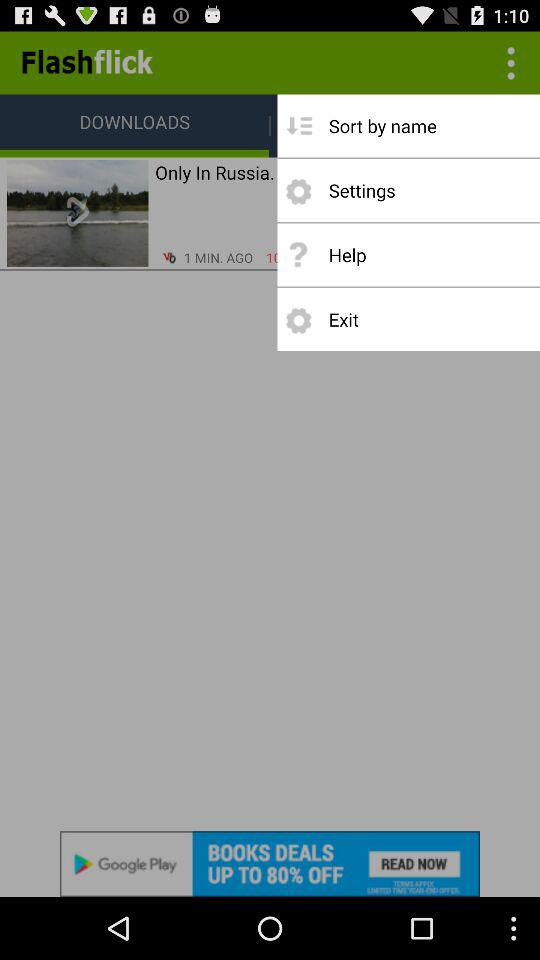What is the application name? The application name is "Flashflick". 